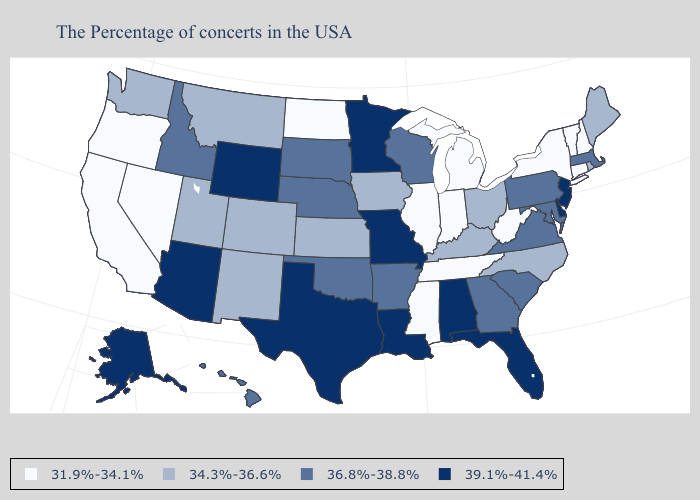Which states hav the highest value in the Northeast?
Write a very short answer. New Jersey. What is the lowest value in the USA?
Write a very short answer. 31.9%-34.1%. Which states hav the highest value in the South?
Give a very brief answer. Delaware, Florida, Alabama, Louisiana, Texas. Which states have the lowest value in the MidWest?
Give a very brief answer. Michigan, Indiana, Illinois, North Dakota. Does New Hampshire have the lowest value in the Northeast?
Short answer required. Yes. Which states hav the highest value in the West?
Keep it brief. Wyoming, Arizona, Alaska. Which states have the lowest value in the MidWest?
Be succinct. Michigan, Indiana, Illinois, North Dakota. What is the lowest value in the USA?
Keep it brief. 31.9%-34.1%. Which states have the highest value in the USA?
Give a very brief answer. New Jersey, Delaware, Florida, Alabama, Louisiana, Missouri, Minnesota, Texas, Wyoming, Arizona, Alaska. Name the states that have a value in the range 34.3%-36.6%?
Give a very brief answer. Maine, Rhode Island, North Carolina, Ohio, Kentucky, Iowa, Kansas, Colorado, New Mexico, Utah, Montana, Washington. How many symbols are there in the legend?
Write a very short answer. 4. Does Hawaii have a lower value than Idaho?
Give a very brief answer. No. Among the states that border Wisconsin , which have the lowest value?
Concise answer only. Michigan, Illinois. Does New Hampshire have a lower value than Michigan?
Be succinct. No. What is the lowest value in states that border Nevada?
Give a very brief answer. 31.9%-34.1%. 